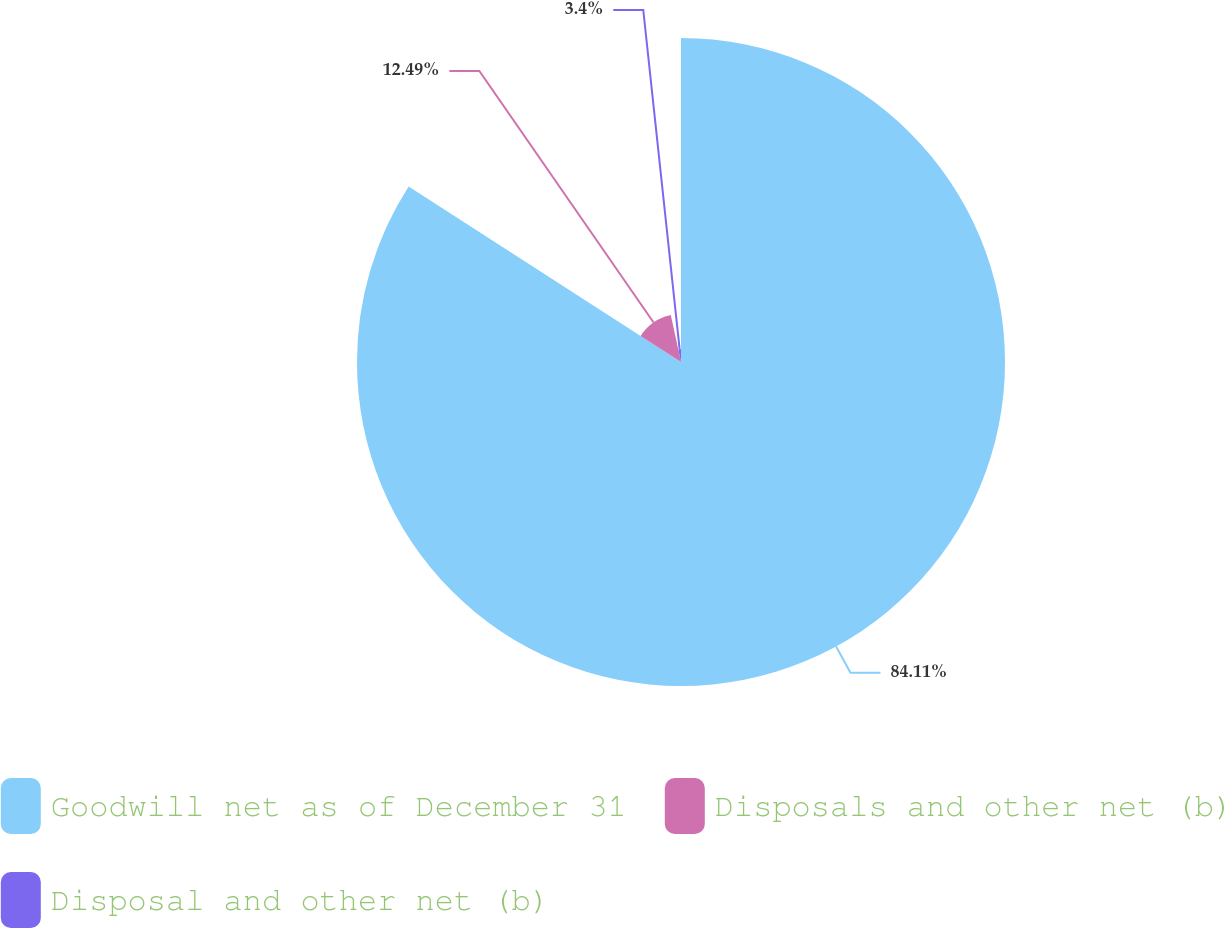Convert chart to OTSL. <chart><loc_0><loc_0><loc_500><loc_500><pie_chart><fcel>Goodwill net as of December 31<fcel>Disposals and other net (b)<fcel>Disposal and other net (b)<nl><fcel>84.11%<fcel>12.49%<fcel>3.4%<nl></chart> 